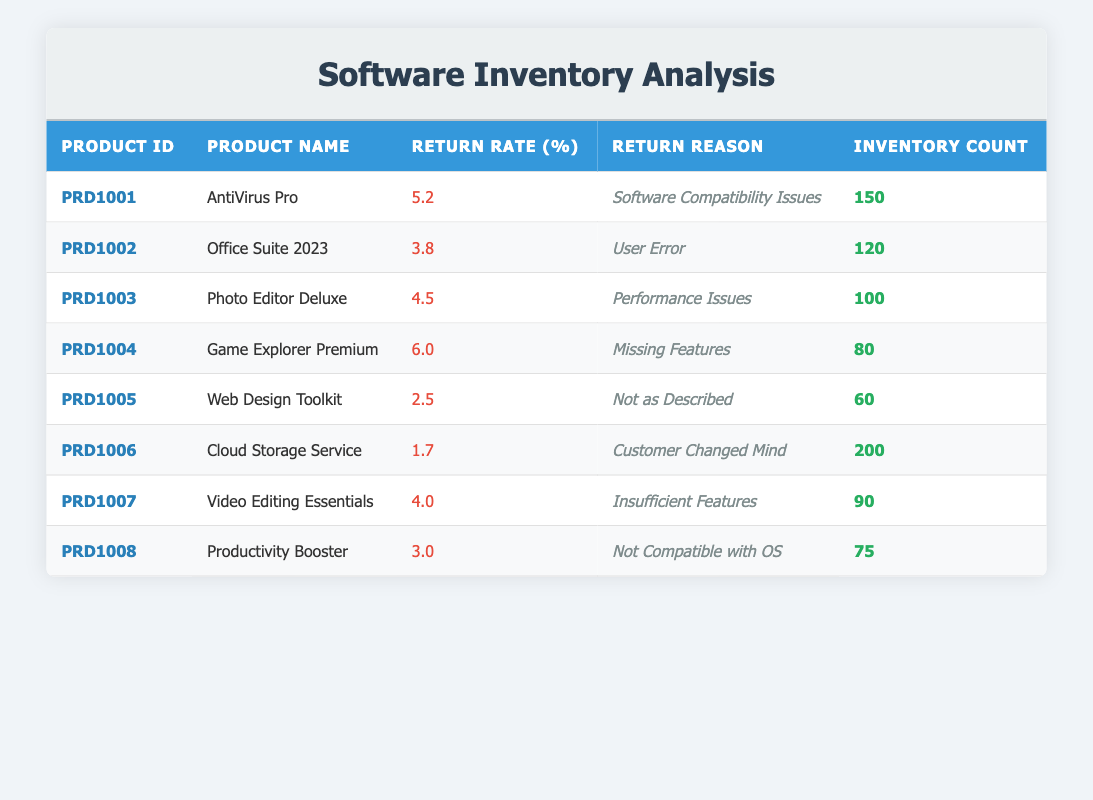What is the return rate of "Game Explorer Premium"? The return rate is found in the table, specifically in the row corresponding to "Game Explorer Premium", which shows a return rate of 6.0%.
Answer: 6.0 What is the return reason for "AntiVirus Pro"? By checking the row for "AntiVirus Pro", the return reason listed is "Software Compatibility Issues".
Answer: Software Compatibility Issues Which product has the highest inventory count? The inventory counts for each product are checked, and "Cloud Storage Service" has the highest count at 200.
Answer: 200 What is the average return rate across all products? The return rates are added together: 5.2 + 3.8 + 4.5 + 6.0 + 2.5 + 1.7 + 4.0 + 3.0 = 31.7. There are 8 products, so the average is 31.7 / 8 = 3.9625, which can be rounded to 3.96%.
Answer: 3.96 Is the return reason for "Web Design Toolkit" related to user error? The return reason for "Web Design Toolkit" is "Not as Described", which does not relate to user error. Therefore, the statement is false.
Answer: No What are the return reasons for products with a return rate higher than 5%? The products with a return rate higher than 5% are "Game Explorer Premium" (6.0%) and "AntiVirus Pro" (5.2%). Their return reasons are "Missing Features" and "Software Compatibility Issues" respectively.
Answer: Missing Features, Software Compatibility Issues Which product would you prioritize for improvement based on return rates? The product with the highest return rate is "Game Explorer Premium" with 6.0%. Therefore, priority for improvement should be given to this product.
Answer: Game Explorer Premium What is the total inventory count for products that have a return rate below 3%? The only product with a return rate below 3% is "Cloud Storage Service" with an inventory count of 200. Hence, the total count is 200.
Answer: 200 